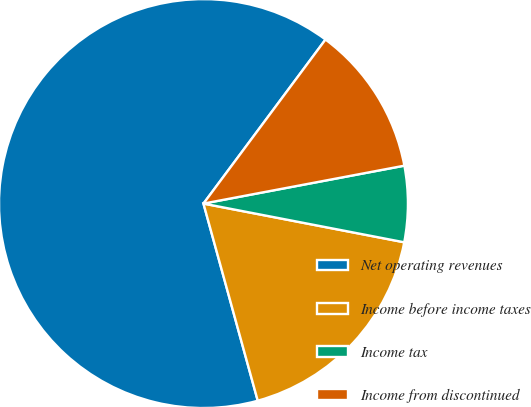Convert chart. <chart><loc_0><loc_0><loc_500><loc_500><pie_chart><fcel>Net operating revenues<fcel>Income before income taxes<fcel>Income tax<fcel>Income from discontinued<nl><fcel>64.45%<fcel>17.69%<fcel>6.0%<fcel>11.85%<nl></chart> 